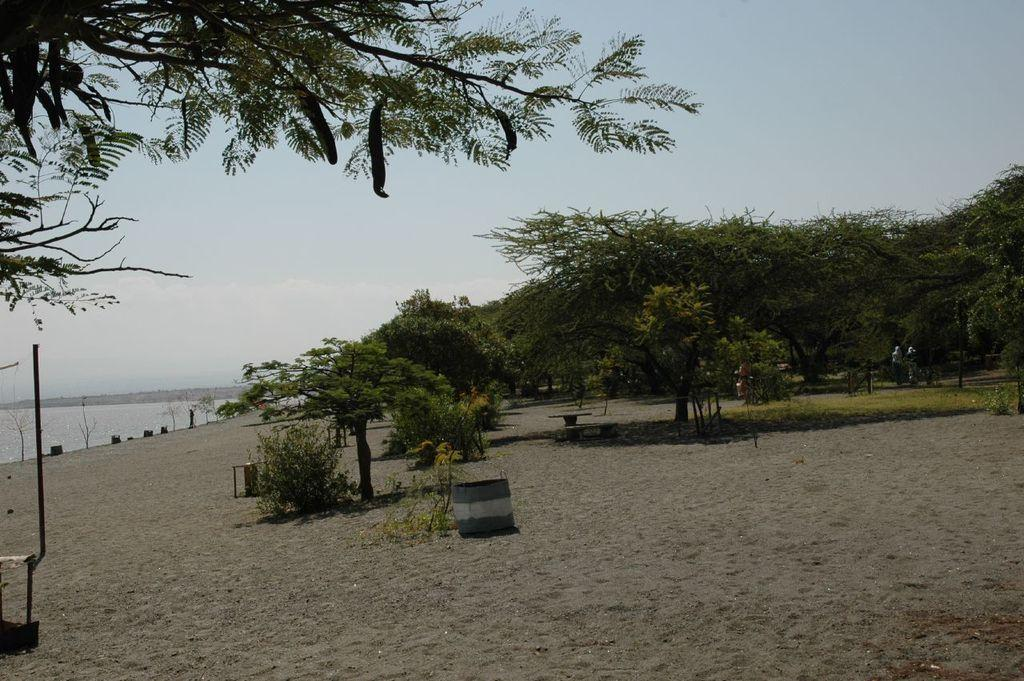What type of surface is visible in the image? There is sand in the image. What objects can be seen on the sand? There is a dustbin and a bench on the sand. What type of vegetation is present in the image? There are trees in the image. What can be seen to the left of the image? There is water visible to the left of the image. What is visible in the background of the image? The sky is visible in the background of the image. How many eggs are visible in the image? There are no eggs present in the image. What type of expression can be seen on the trees in the image? Trees do not have expressions, so this question cannot be answered. 